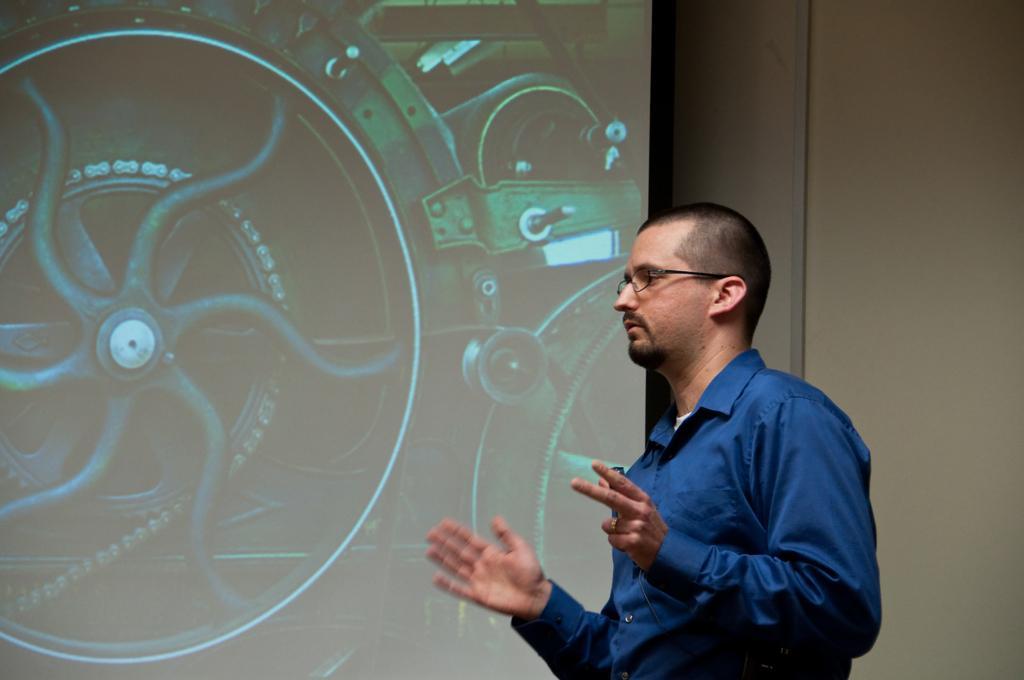Describe this image in one or two sentences. In the picture I can see a man is standing. The man is wearing spectacles and a blue color shirt. In the background I can see a projector screen. In the screen I can see some objects. 